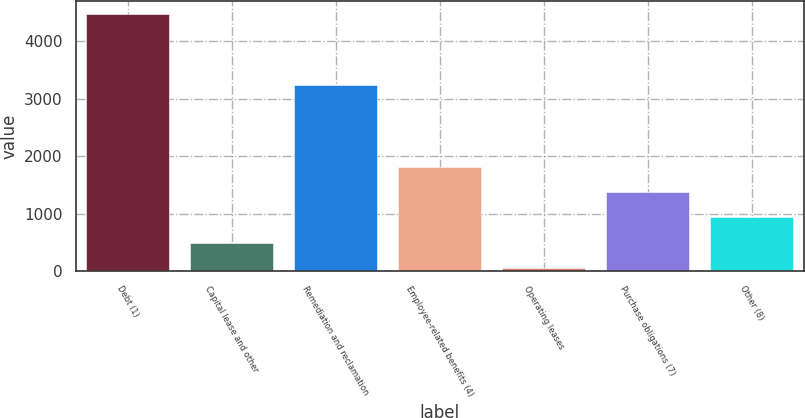<chart> <loc_0><loc_0><loc_500><loc_500><bar_chart><fcel>Debt (1)<fcel>Capital lease and other<fcel>Remediation and reclamation<fcel>Employee-related benefits (4)<fcel>Operating leases<fcel>Purchase obligations (7)<fcel>Other (8)<nl><fcel>4476<fcel>494.4<fcel>3242<fcel>1821.6<fcel>52<fcel>1379.2<fcel>936.8<nl></chart> 